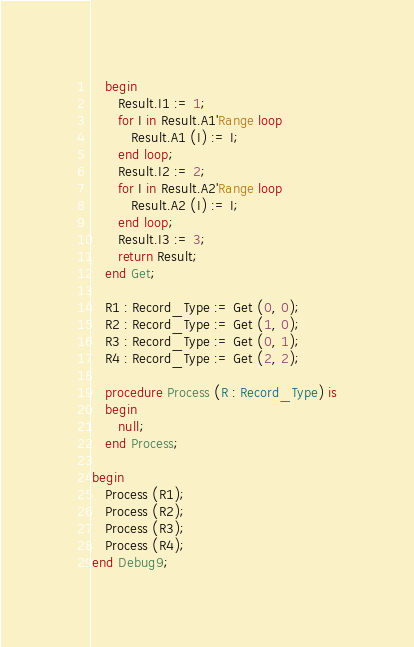<code> <loc_0><loc_0><loc_500><loc_500><_Ada_>   begin
      Result.I1 := 1;
      for I in Result.A1'Range loop
         Result.A1 (I) := I;
      end loop;
      Result.I2 := 2;
      for I in Result.A2'Range loop
         Result.A2 (I) := I;
      end loop;
      Result.I3 := 3;
      return Result;
   end Get;

   R1 : Record_Type := Get (0, 0);
   R2 : Record_Type := Get (1, 0);
   R3 : Record_Type := Get (0, 1);
   R4 : Record_Type := Get (2, 2);

   procedure Process (R : Record_Type) is
   begin
      null;
   end Process;

begin
   Process (R1);
   Process (R2);
   Process (R3);
   Process (R4);
end Debug9;
</code> 